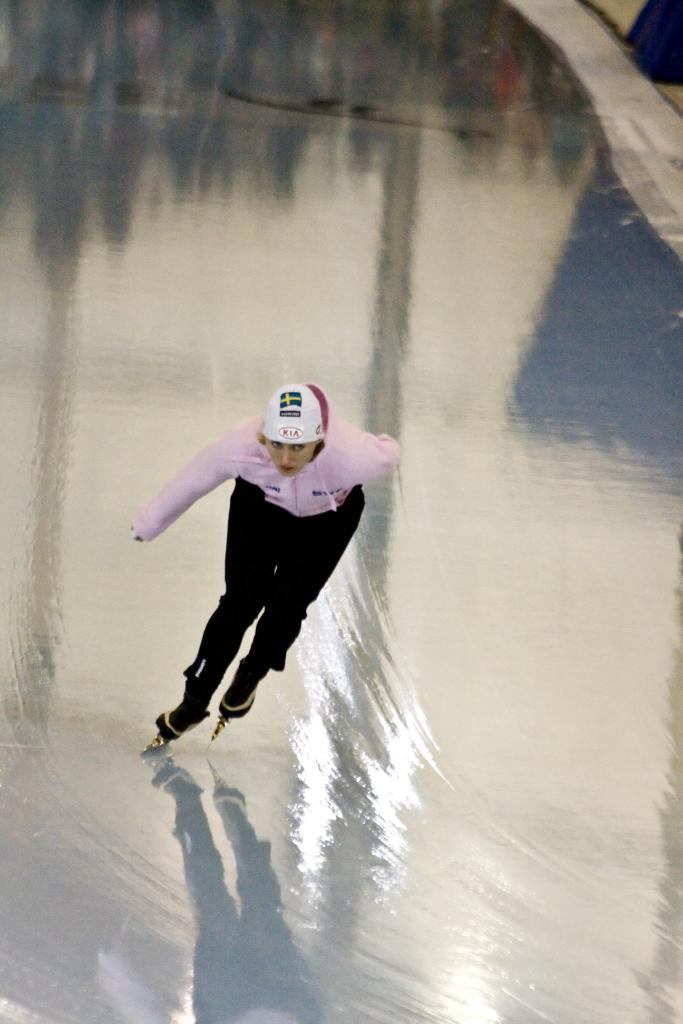Who is the main subject in the image? There is a lady in the image. What is the lady wearing on her head? The lady is wearing a helmet. What activity is the lady engaged in? The lady is ice skating. What type of surface is visible in the image? There is ice on the ground in the image. What type of copper material can be seen in the image? There is no copper material present in the image. Can you see a duck swimming in the ice in the image? There is no duck present in the image; it features a lady ice skating on the ice. 